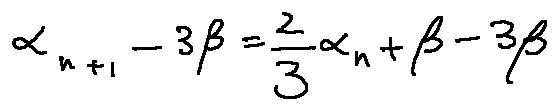Convert formula to latex. <formula><loc_0><loc_0><loc_500><loc_500>\alpha _ { n + 1 } - 3 \beta = \frac { 2 } { 3 } \alpha _ { n } + \beta - 3 \beta</formula> 